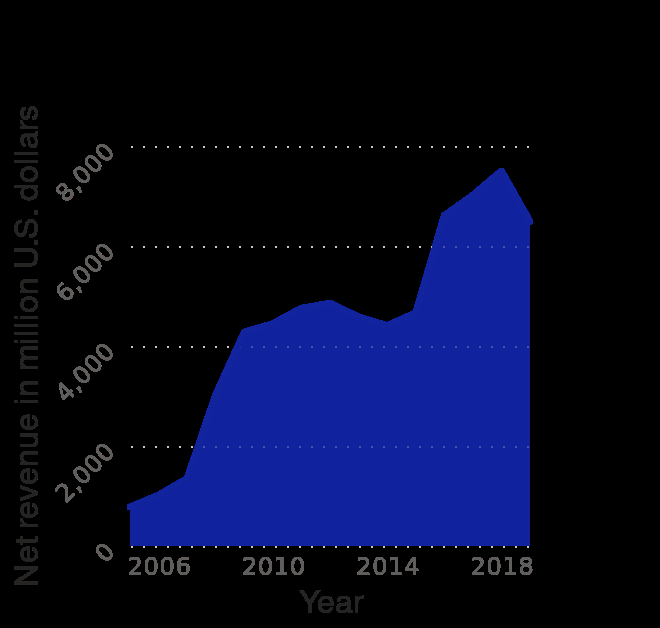<image>
What is the range of the y-axis? The range of the y-axis is from 0 to 8,000 million U.S. dollars. please summary the statistics and relations of the chart We see a steady growth in annual net revenue of Activision blizzard from 2006 until before 2018. 